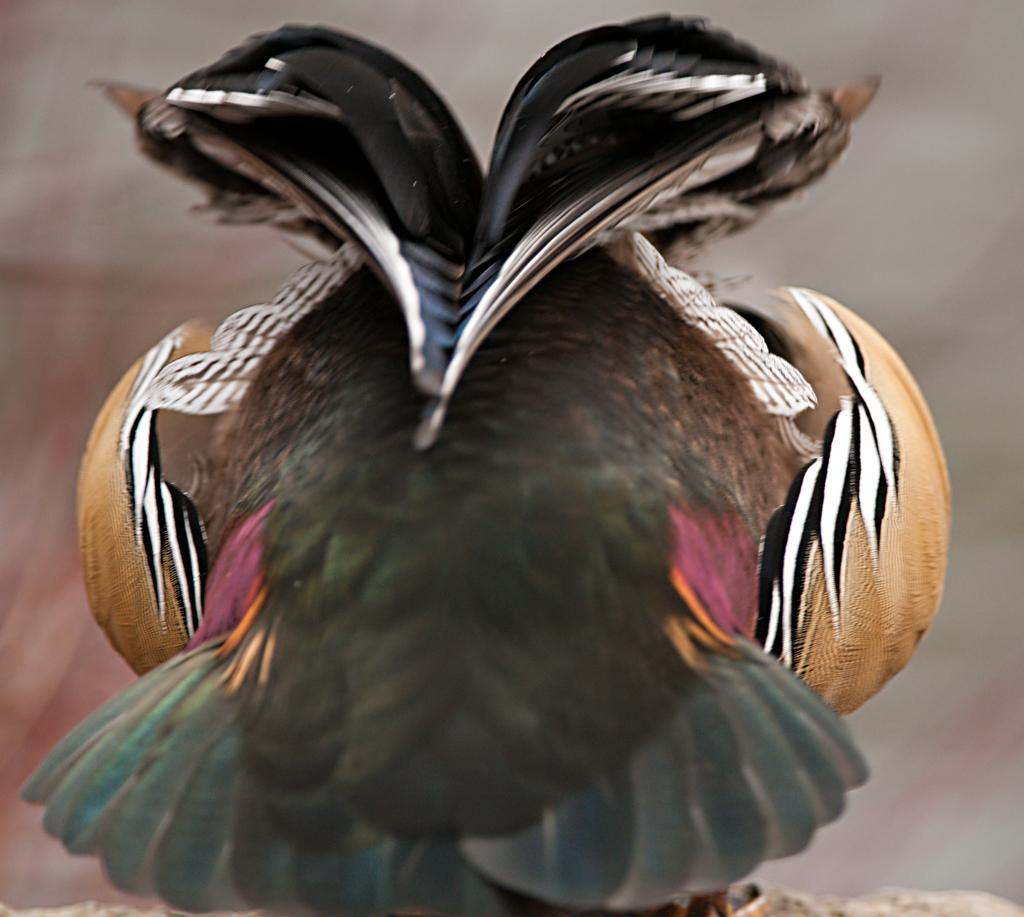What type of animal can be seen in the image? There is a bird in the image. Where is the bird located? The bird is on a rock. Can you describe the background of the image? The background of the image is blurry. What is the purpose of the roof in the image? There is no roof present in the image, as it features a bird on a rock with a blurry background. 